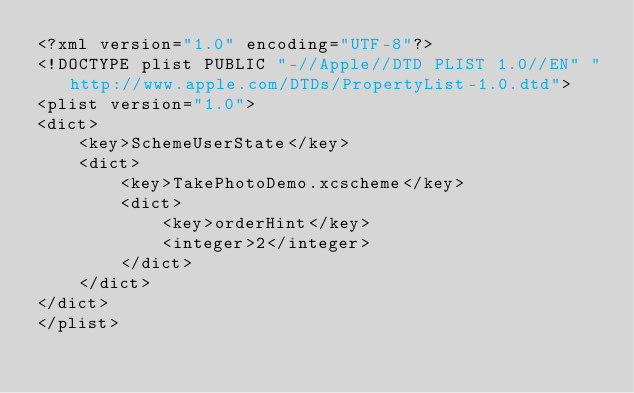<code> <loc_0><loc_0><loc_500><loc_500><_XML_><?xml version="1.0" encoding="UTF-8"?>
<!DOCTYPE plist PUBLIC "-//Apple//DTD PLIST 1.0//EN" "http://www.apple.com/DTDs/PropertyList-1.0.dtd">
<plist version="1.0">
<dict>
	<key>SchemeUserState</key>
	<dict>
		<key>TakePhotoDemo.xcscheme</key>
		<dict>
			<key>orderHint</key>
			<integer>2</integer>
		</dict>
	</dict>
</dict>
</plist>
</code> 